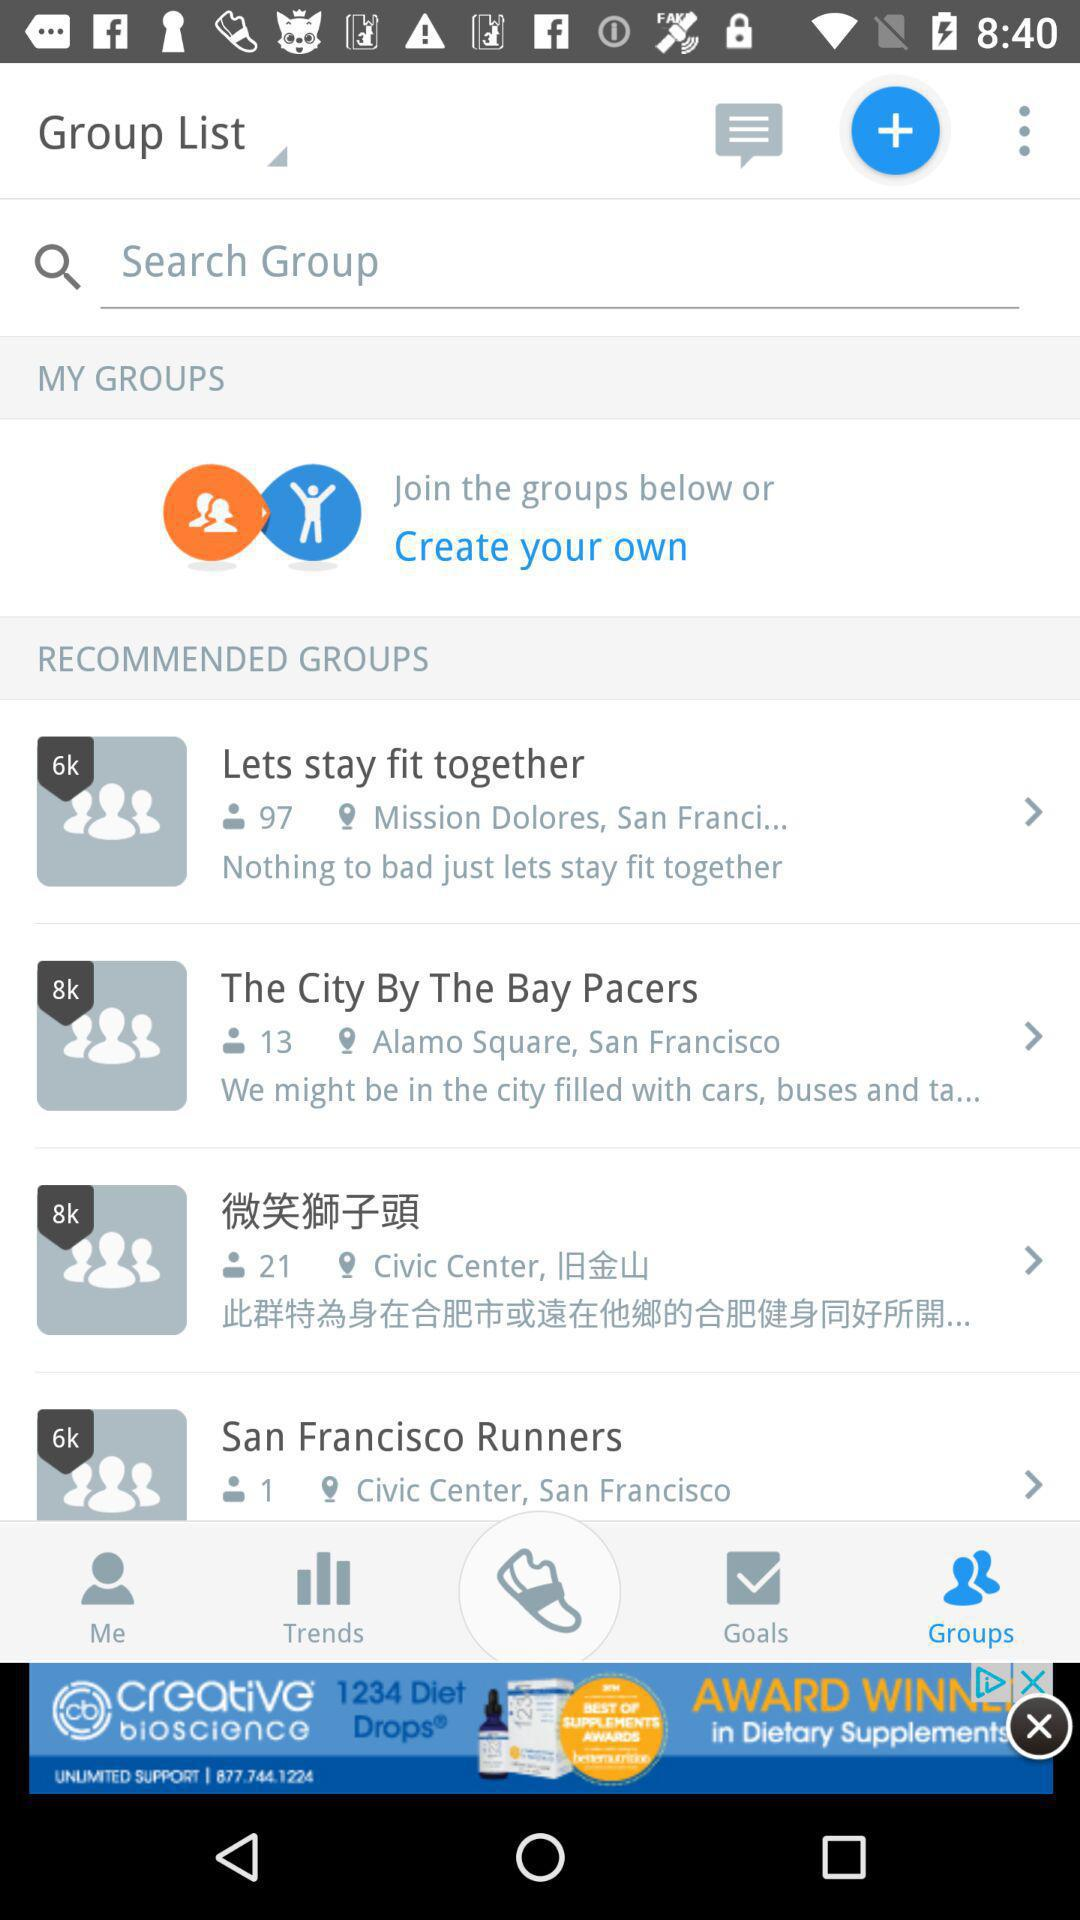How many people have joined the "Lets stay fit together" group? The number of people that have joined the "Lets stay fit together" group is 97. 